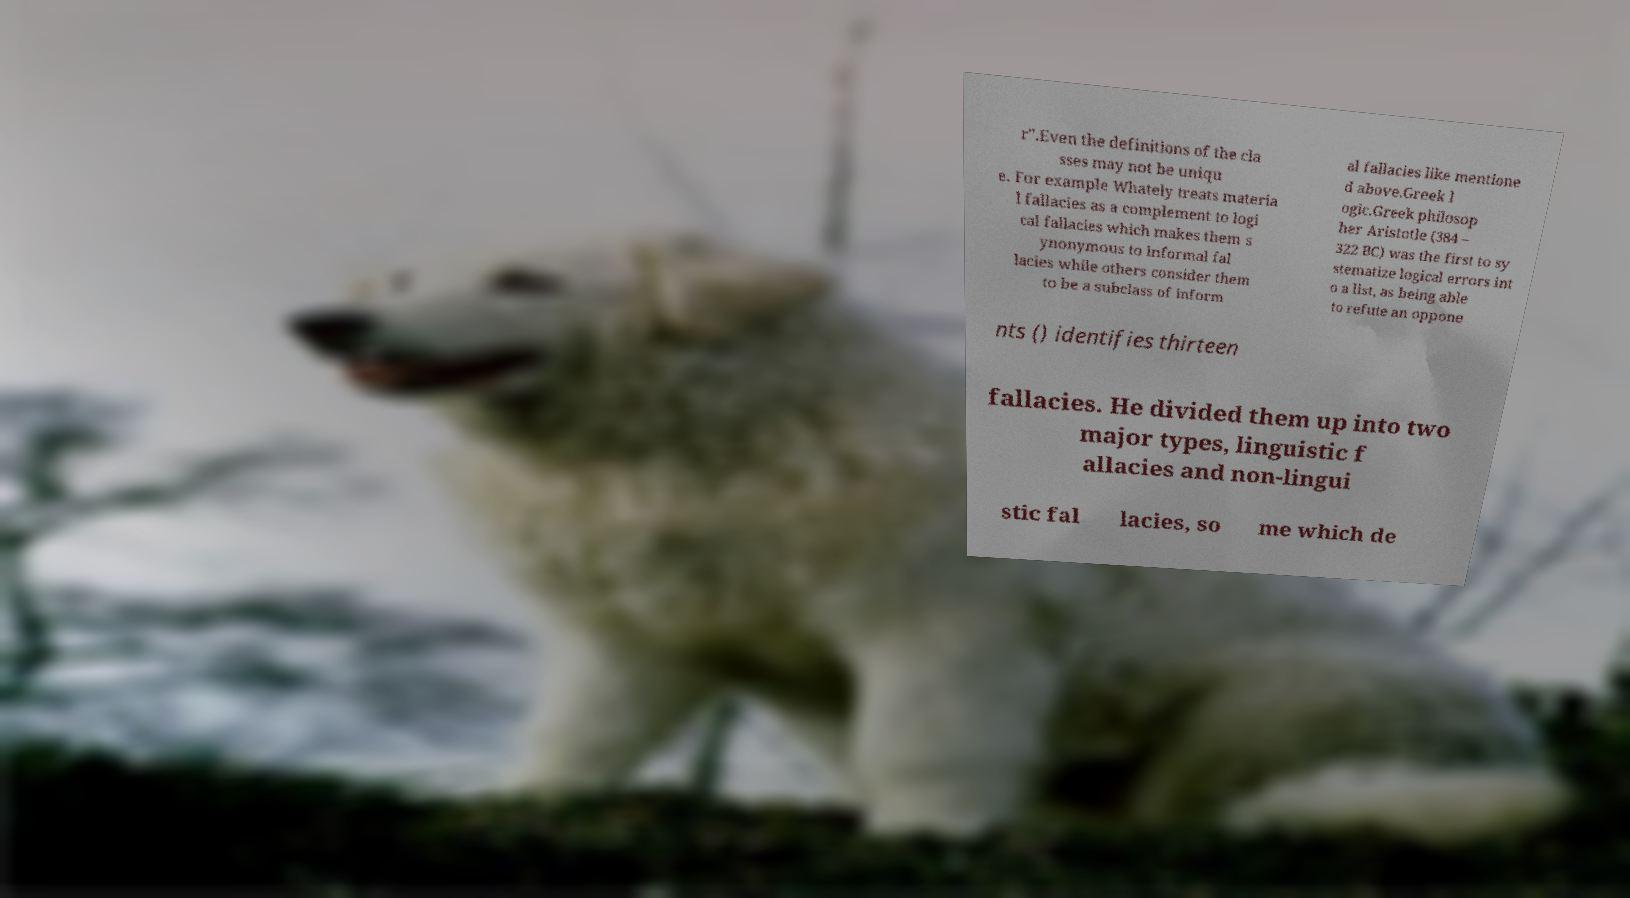For documentation purposes, I need the text within this image transcribed. Could you provide that? r".Even the definitions of the cla sses may not be uniqu e. For example Whately treats materia l fallacies as a complement to logi cal fallacies which makes them s ynonymous to informal fal lacies while others consider them to be a subclass of inform al fallacies like mentione d above.Greek l ogic.Greek philosop her Aristotle (384 – 322 BC) was the first to sy stematize logical errors int o a list, as being able to refute an oppone nts () identifies thirteen fallacies. He divided them up into two major types, linguistic f allacies and non-lingui stic fal lacies, so me which de 